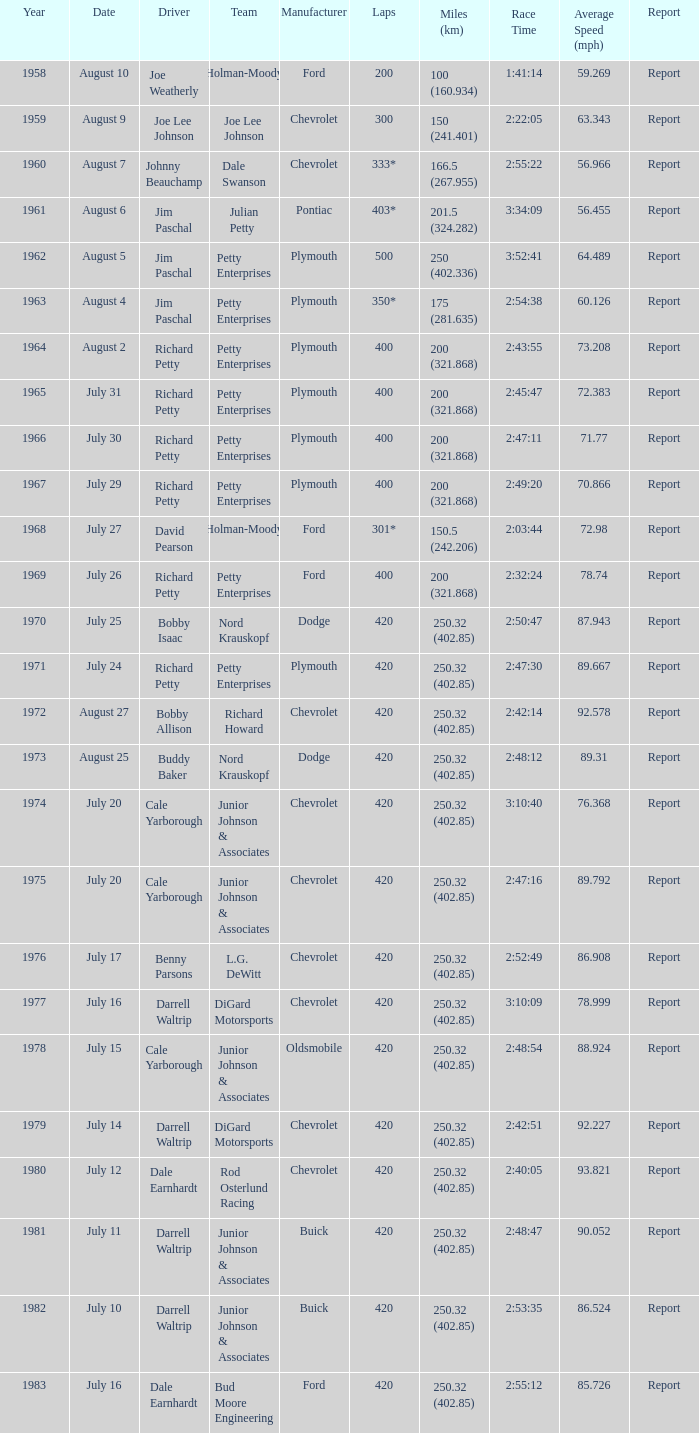In 1968, what was the date of the race? July 27. 